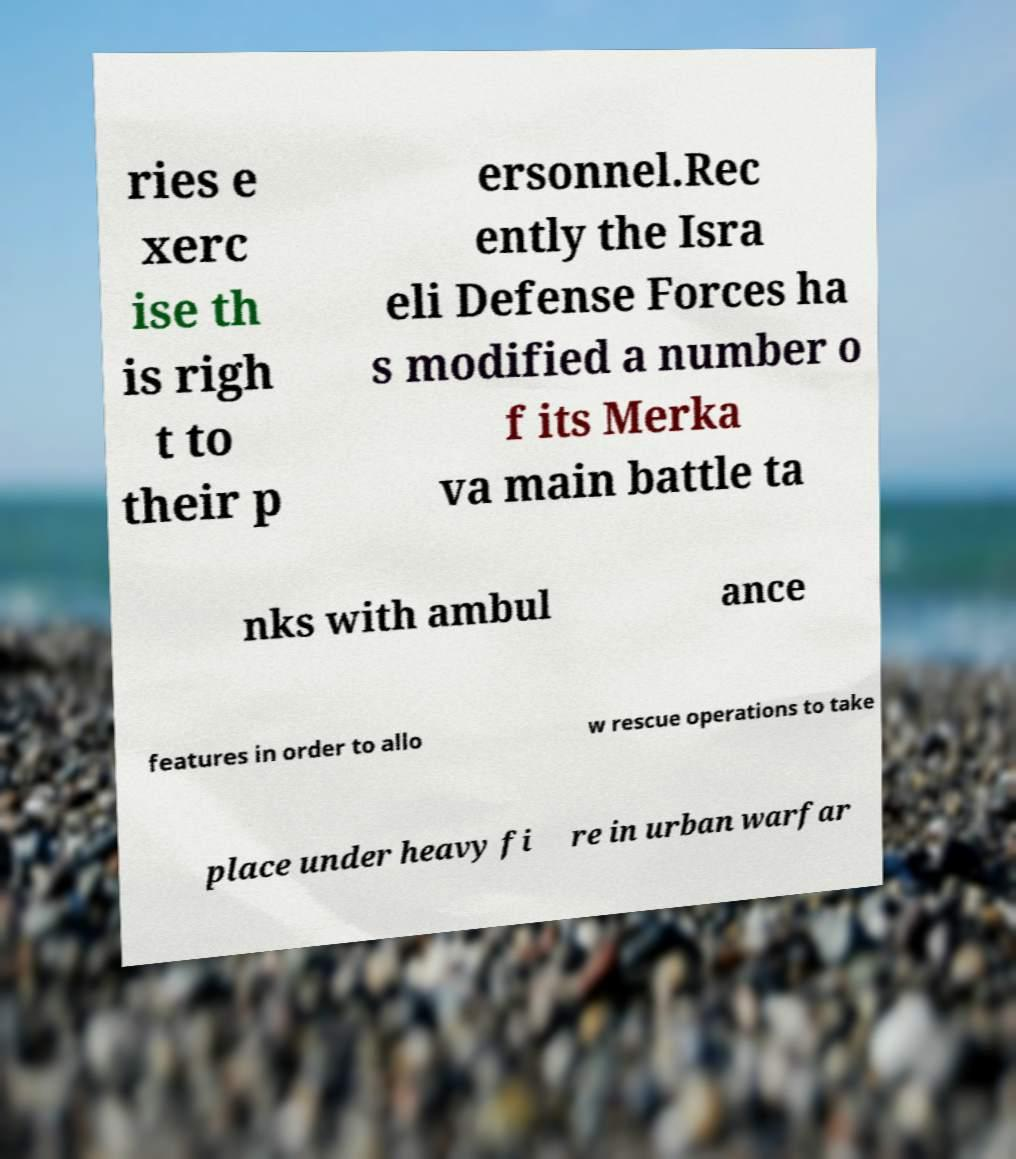Please identify and transcribe the text found in this image. ries e xerc ise th is righ t to their p ersonnel.Rec ently the Isra eli Defense Forces ha s modified a number o f its Merka va main battle ta nks with ambul ance features in order to allo w rescue operations to take place under heavy fi re in urban warfar 